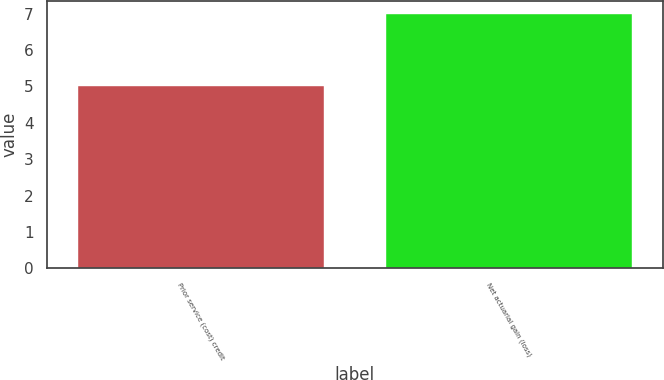<chart> <loc_0><loc_0><loc_500><loc_500><bar_chart><fcel>Prior service (cost) credit<fcel>Net actuarial gain (loss)<nl><fcel>5<fcel>7<nl></chart> 